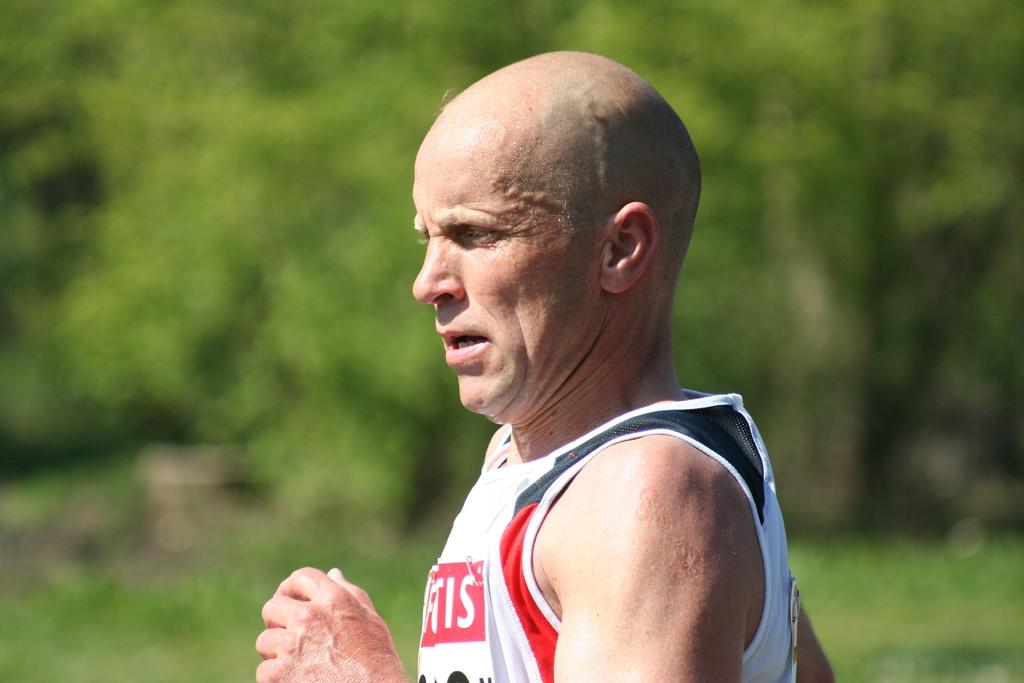<image>
Present a compact description of the photo's key features. Man wearing a tanktop with a letter S at the end is running in a race. 